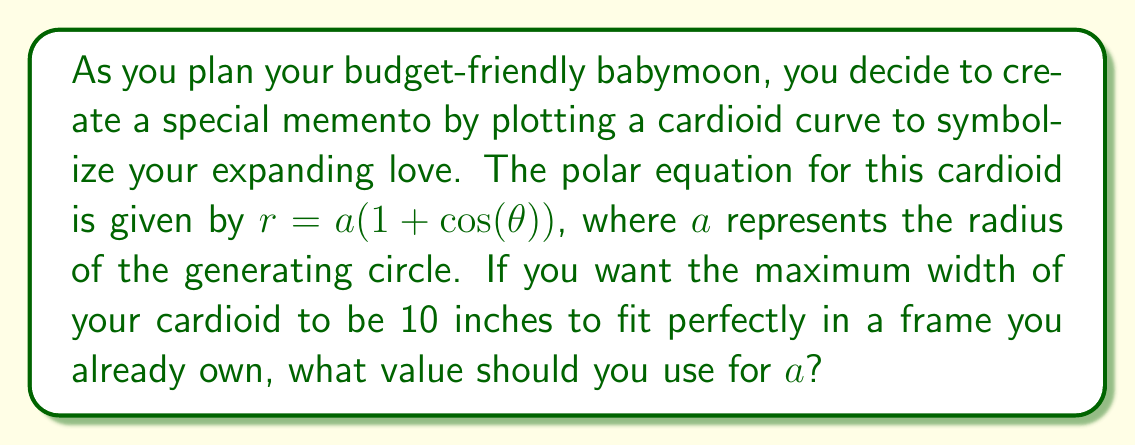Solve this math problem. Let's approach this step-by-step:

1) The cardioid equation is given as $r = a(1 + \cos(\theta))$.

2) The maximum width of the cardioid occurs when $\theta = 0$ and $\theta = \pi$. At these points, $\cos(\theta) = 1$ and $\cos(\theta) = -1$ respectively.

3) When $\theta = 0$:
   $r_{\text{max}} = a(1 + 1) = 2a$

4) When $\theta = \pi$:
   $r_{\text{min}} = a(1 - 1) = 0$

5) The total width of the cardioid is the distance from the rightmost point to the leftmost point, which is $r_{\text{max}} + r_{\text{min}} = 2a + 0 = 2a$.

6) We're told that this maximum width should be 10 inches. So:

   $2a = 10$

7) Solving for $a$:
   $a = 5$

Therefore, to create a cardioid with a maximum width of 10 inches, you should use $a = 5$ in the equation $r = a(1 + \cos(\theta))$.

[asy]
import graph;
size(200);
real r(real t) {return 5*(1+cos(t));}
draw(polargraph(r,0,2*pi,operator ..),blue);
draw(circle((5,0),5),dashed);
draw((0,0)--(10,0),Arrow);
draw((0,0)--(0,10),Arrow);
label("10 inches",(-1,5),W);
[/asy]
Answer: $a = 5$ inches 